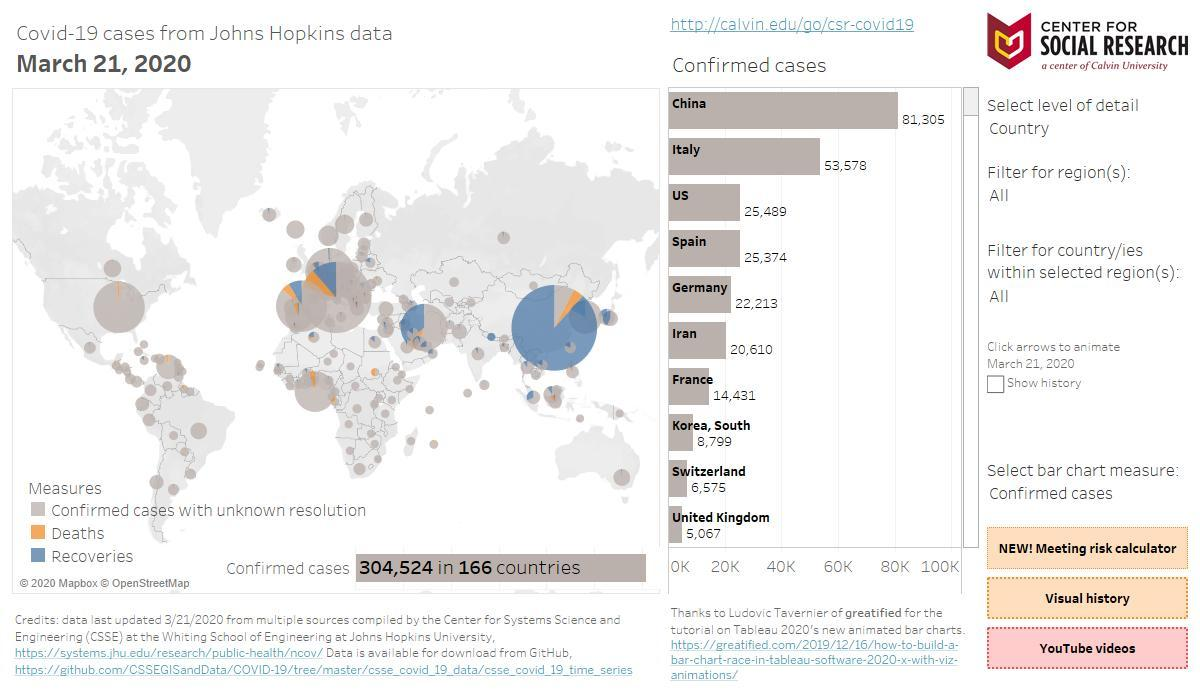How much more is a number of confirmed cases in China higher than Italy?
Answer the question with a short phrase. 27727 Which countries have confirmed cases less than 10000? Korea,South, Switzerland, United Kingdom Which are the countries that have confirmed cases between 25000 and 50000? US, Spain How much more, is the number of confirmed cases in Germany higher than Iran? 1603 What is the 'selected level of detail'? Country Which are the countries that have more than 50000 confirmed cases? China, Italy Which country has the second least number of confirmed cases? Switzerland What colour is used to represent deaths on the map- blue white or yellow? Yellow Which country has the second highest number of confirmed cases? Italy What is the 'bar chart measure' selected for the plot? Confirmed cases What is the 'filter for region(s)' opted? All 